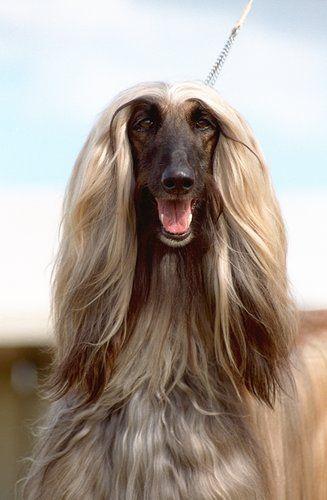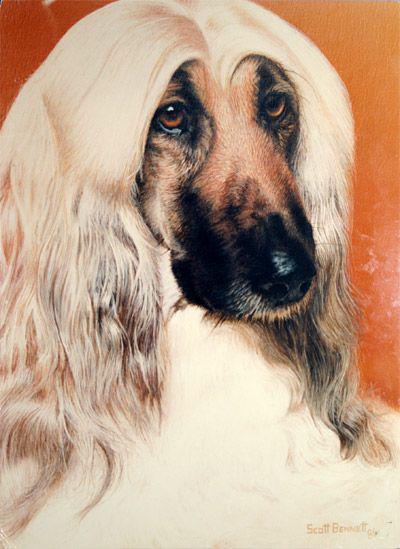The first image is the image on the left, the second image is the image on the right. Assess this claim about the two images: "A leash extends diagonally from a top corner to one of the afghan hounds.". Correct or not? Answer yes or no. Yes. 